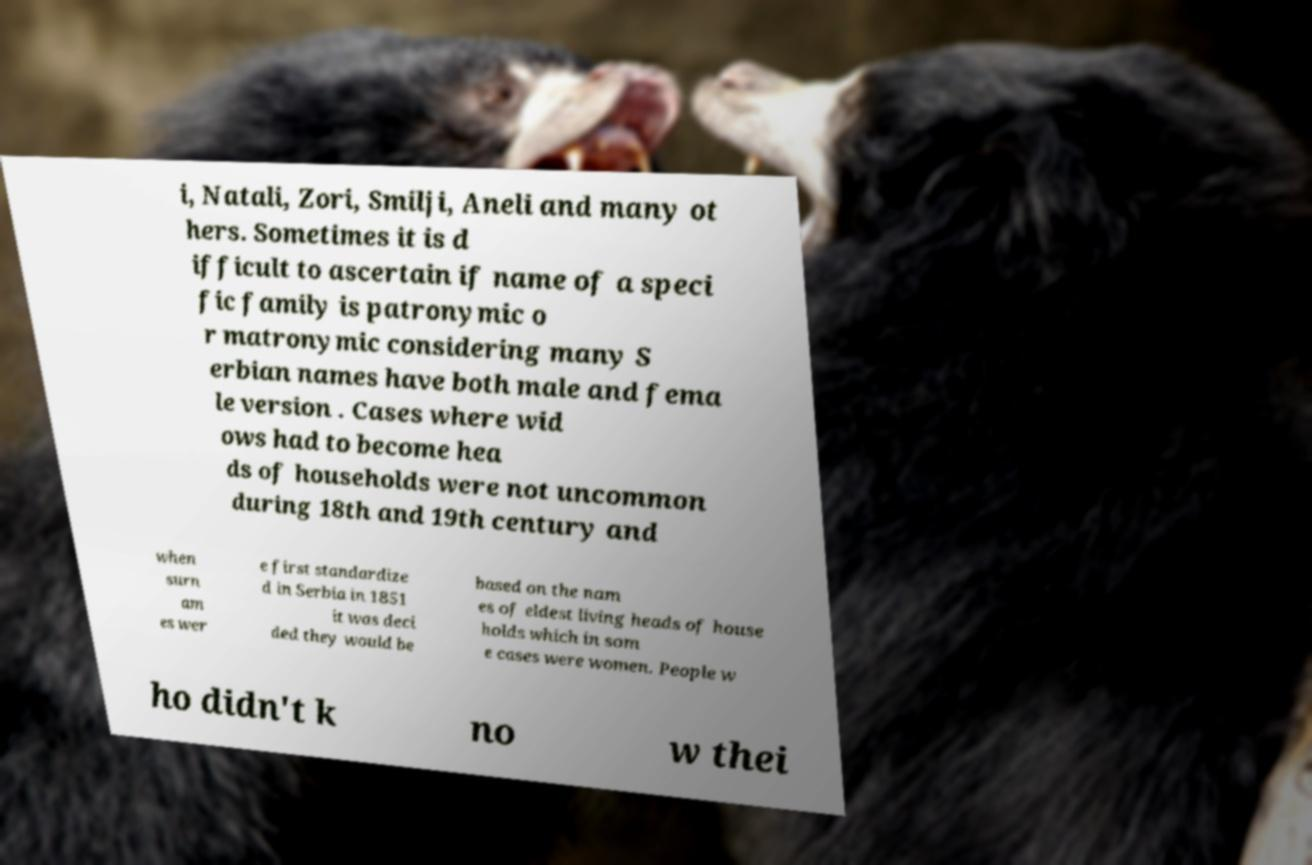Can you read and provide the text displayed in the image?This photo seems to have some interesting text. Can you extract and type it out for me? i, Natali, Zori, Smilji, Aneli and many ot hers. Sometimes it is d ifficult to ascertain if name of a speci fic family is patronymic o r matronymic considering many S erbian names have both male and fema le version . Cases where wid ows had to become hea ds of households were not uncommon during 18th and 19th century and when surn am es wer e first standardize d in Serbia in 1851 it was deci ded they would be based on the nam es of eldest living heads of house holds which in som e cases were women. People w ho didn't k no w thei 